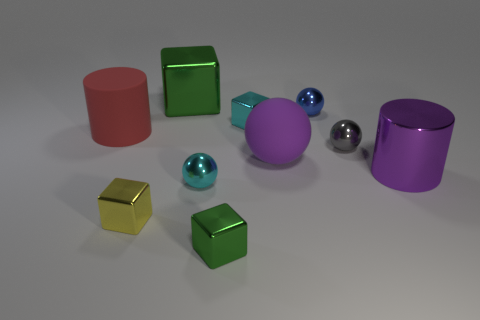How many green blocks must be subtracted to get 1 green blocks? 1 Subtract 1 spheres. How many spheres are left? 3 Subtract all blocks. How many objects are left? 6 Subtract all metallic cylinders. Subtract all green objects. How many objects are left? 7 Add 7 tiny cyan metal things. How many tiny cyan metal things are left? 9 Add 2 tiny yellow balls. How many tiny yellow balls exist? 2 Subtract 0 purple blocks. How many objects are left? 10 